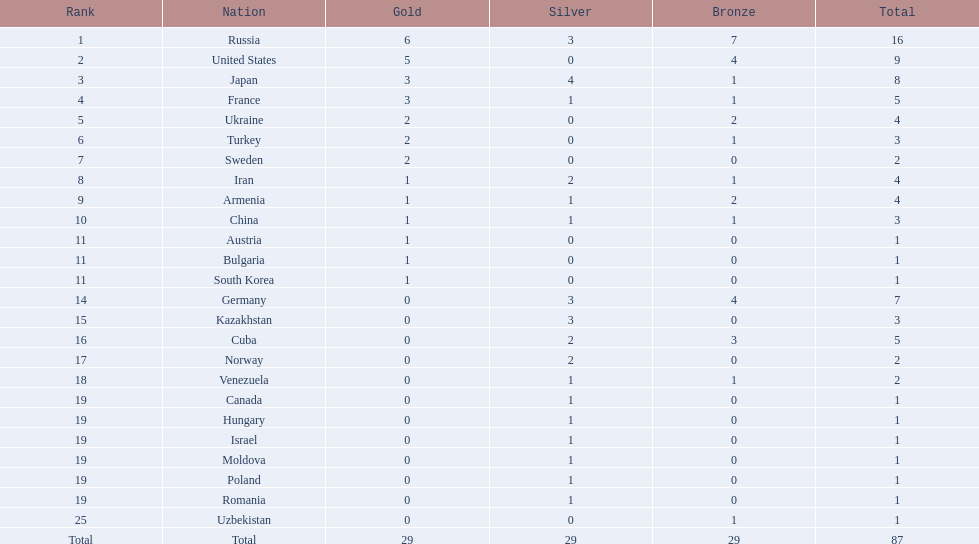What position did iran hold? 8. What position did germany hold? 14. Out of iran and germany, which one was not among the top 10? Germany. 